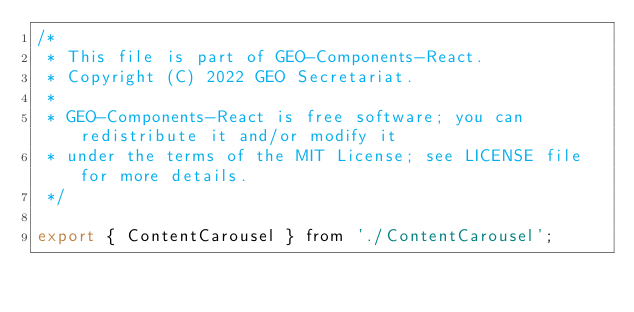<code> <loc_0><loc_0><loc_500><loc_500><_JavaScript_>/*
 * This file is part of GEO-Components-React.
 * Copyright (C) 2022 GEO Secretariat.
 *
 * GEO-Components-React is free software; you can redistribute it and/or modify it
 * under the terms of the MIT License; see LICENSE file for more details.
 */

export { ContentCarousel } from './ContentCarousel';
</code> 